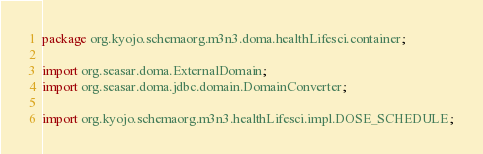<code> <loc_0><loc_0><loc_500><loc_500><_Java_>package org.kyojo.schemaorg.m3n3.doma.healthLifesci.container;

import org.seasar.doma.ExternalDomain;
import org.seasar.doma.jdbc.domain.DomainConverter;

import org.kyojo.schemaorg.m3n3.healthLifesci.impl.DOSE_SCHEDULE;</code> 